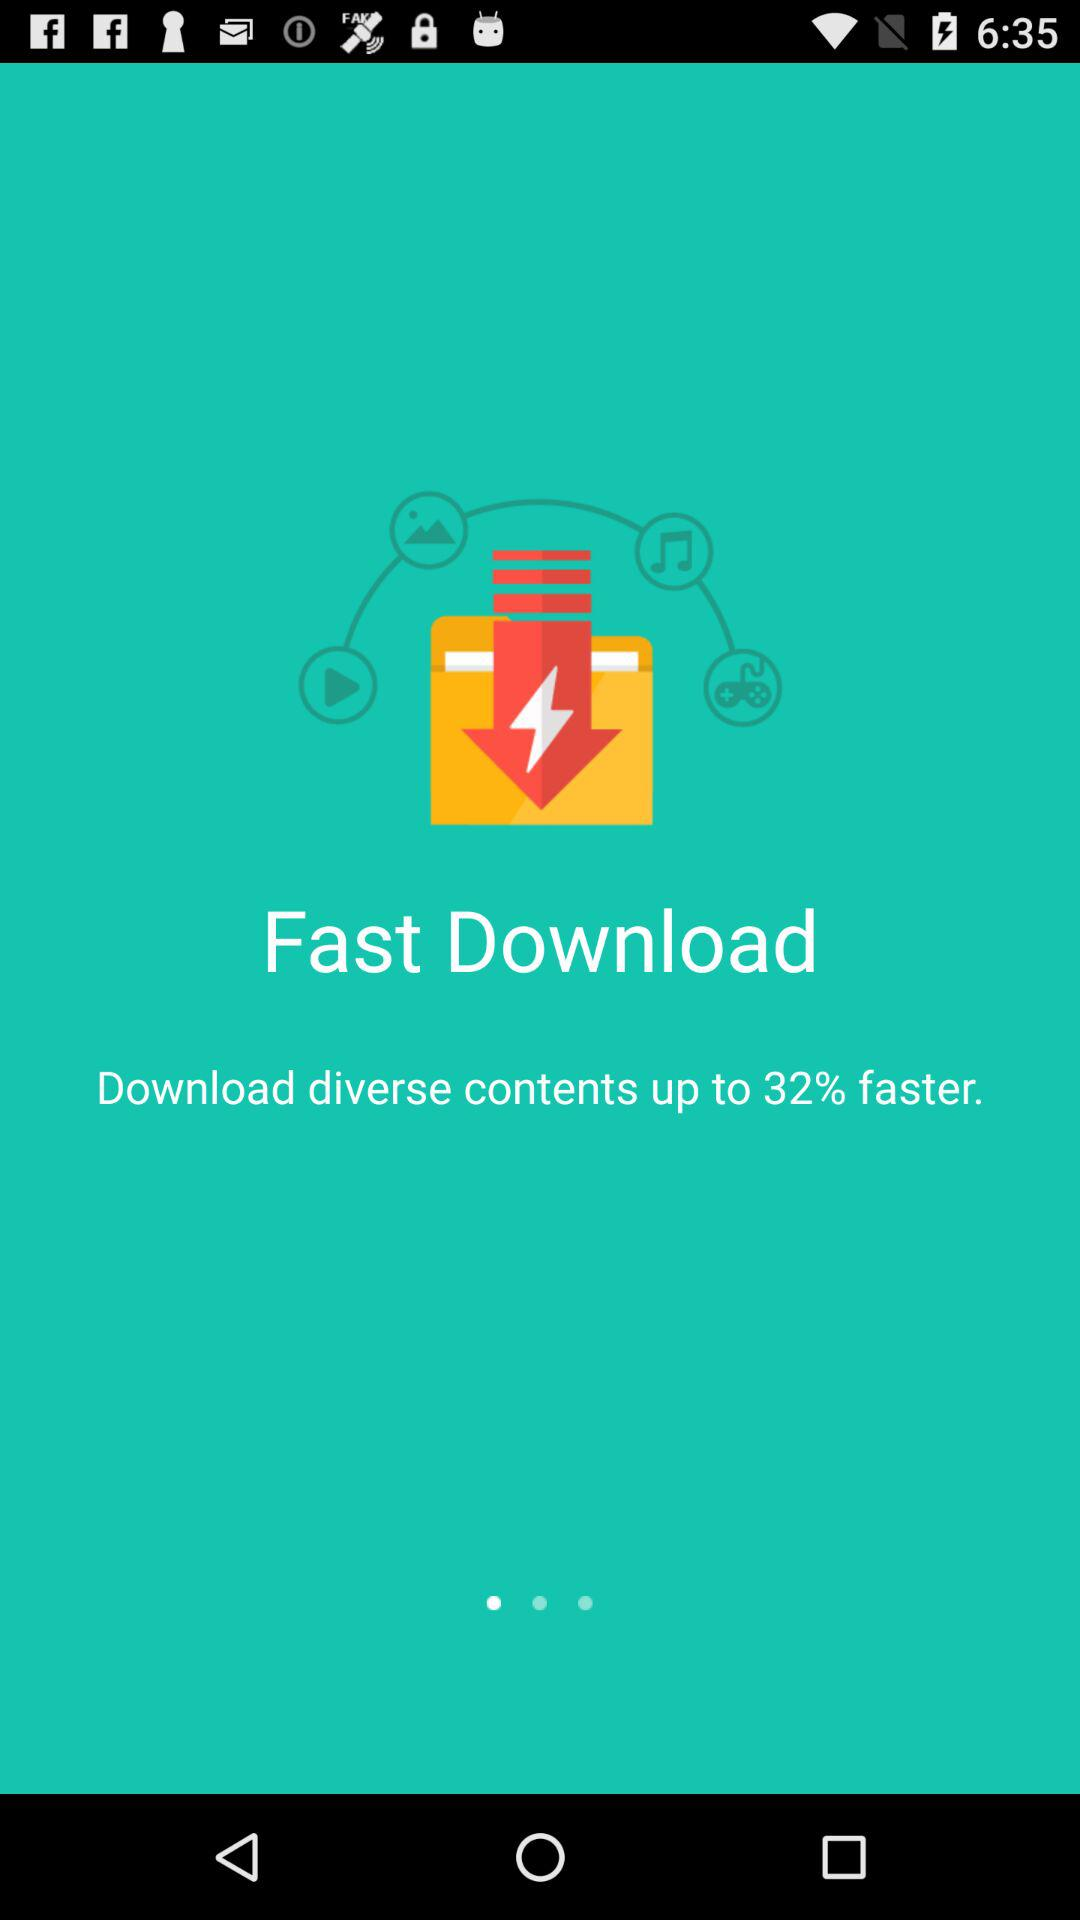How much faster will the contents download, in percentage? The contents will download up to 32% faster. 